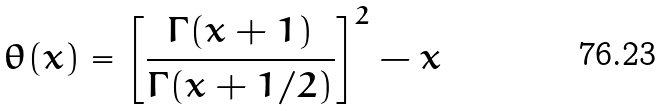Convert formula to latex. <formula><loc_0><loc_0><loc_500><loc_500>\theta ( x ) = \left [ \frac { \Gamma ( x + 1 ) } { \Gamma ( x + 1 / 2 ) } \right ] ^ { 2 } - x</formula> 